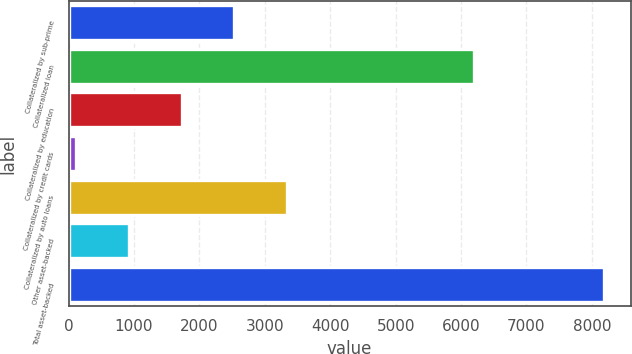<chart> <loc_0><loc_0><loc_500><loc_500><bar_chart><fcel>Collateralized by sub-prime<fcel>Collateralized loan<fcel>Collateralized by education<fcel>Collateralized by credit cards<fcel>Collateralized by auto loans<fcel>Other asset-backed<fcel>Total asset-backed<nl><fcel>2535.8<fcel>6196<fcel>1729.2<fcel>116<fcel>3342.4<fcel>922.6<fcel>8182<nl></chart> 